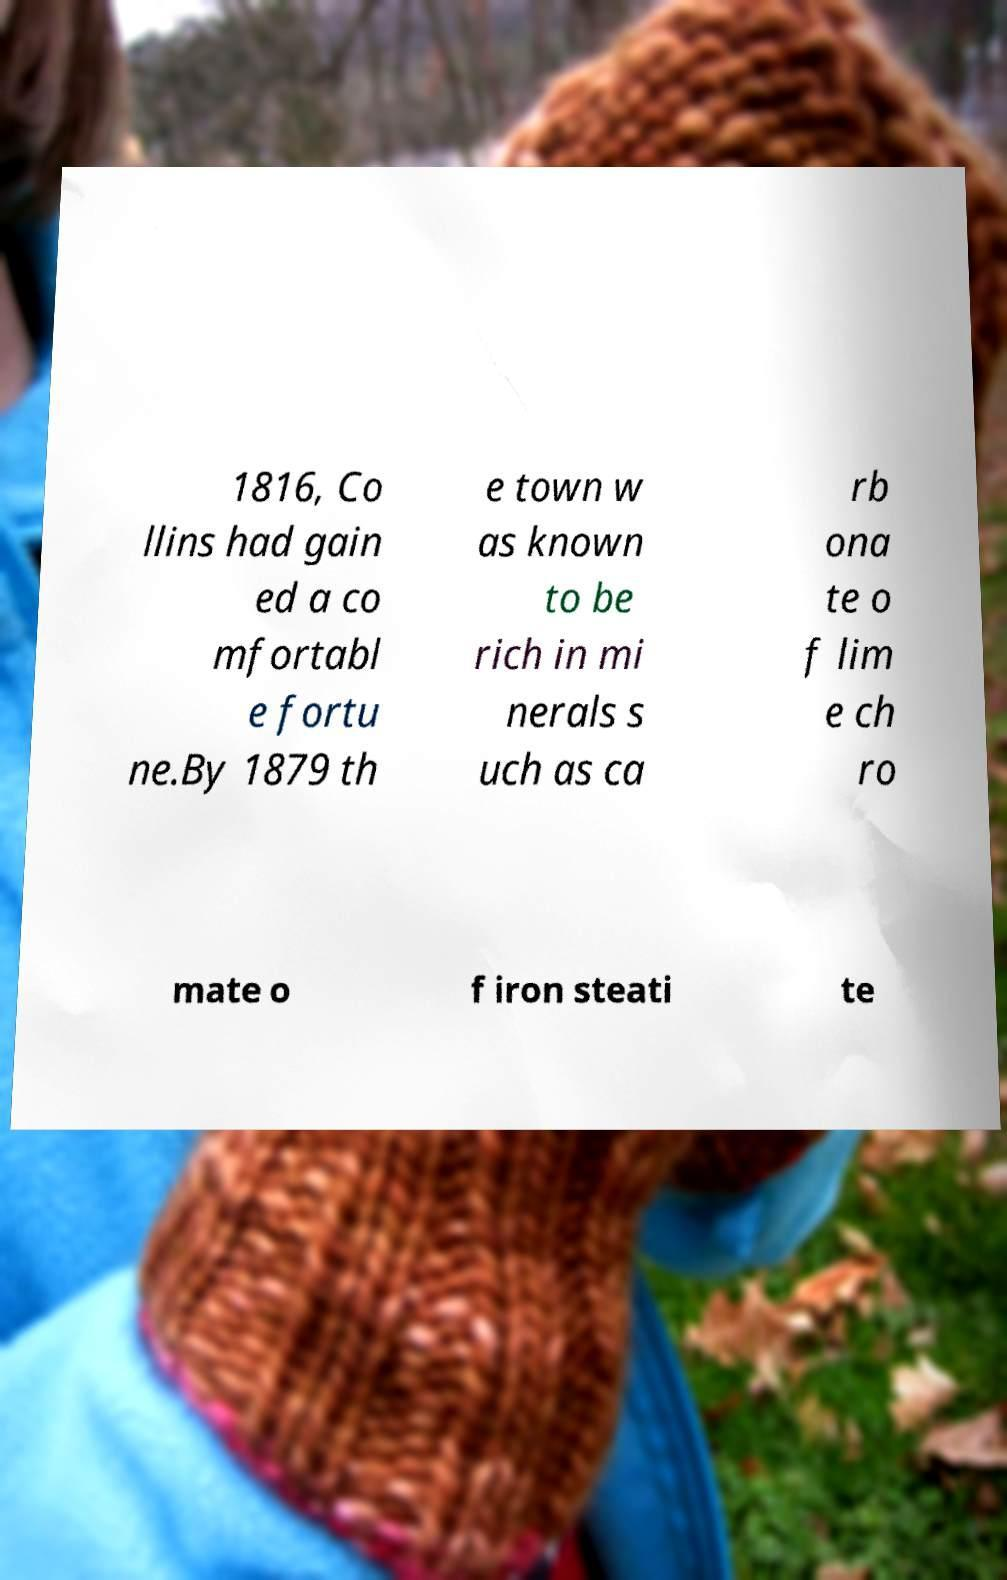Could you assist in decoding the text presented in this image and type it out clearly? 1816, Co llins had gain ed a co mfortabl e fortu ne.By 1879 th e town w as known to be rich in mi nerals s uch as ca rb ona te o f lim e ch ro mate o f iron steati te 